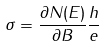Convert formula to latex. <formula><loc_0><loc_0><loc_500><loc_500>\sigma = \frac { \partial N ( E ) } { \partial B } \frac { h } { e }</formula> 